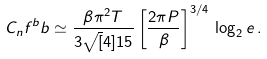<formula> <loc_0><loc_0><loc_500><loc_500>C _ { n } f ^ { b } b \simeq \frac { \beta \pi ^ { 2 } T } { 3 \sqrt { [ } 4 ] { 1 5 } } \left [ \frac { 2 \pi P } { \beta } \right ] ^ { 3 / 4 } \, \log _ { 2 } e \, .</formula> 